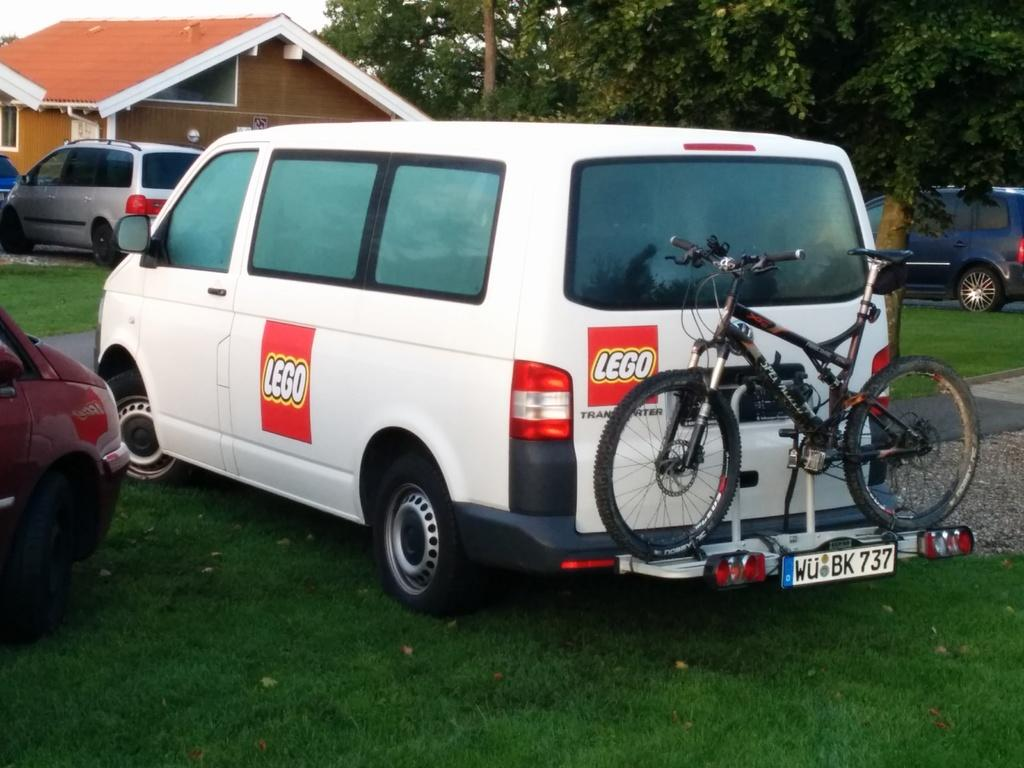What type of vehicles can be seen in the image? There are cars in the image. Where are the cars located? The cars are on the ground. What type of vegetation is near the cars? There are trees beside the cars. What can be seen in the distance behind the cars? There is a house in the background of the image. How many hydrants are visible in the image? There are no hydrants present in the image. What type of crowd can be seen gathering around the cars in the image? There is no crowd visible in the image; it only shows the cars, trees, and the house in the background. 